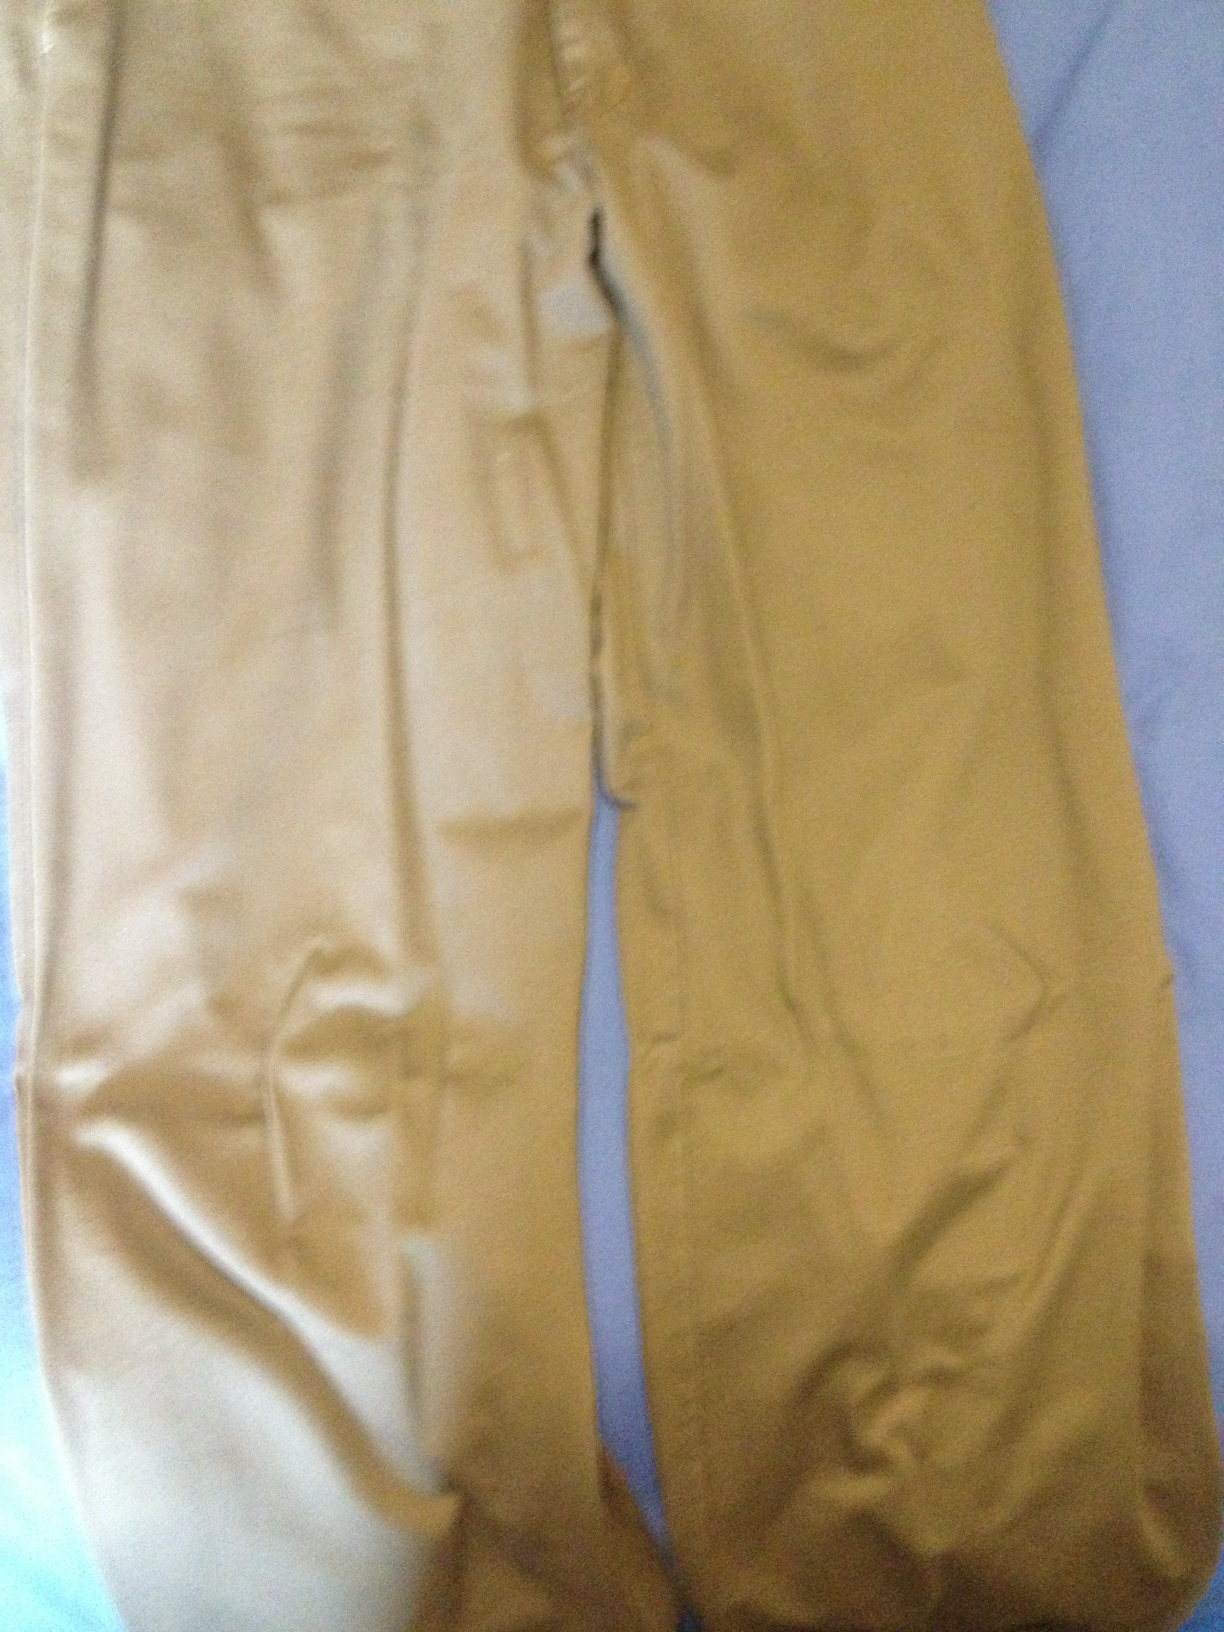What material do these trousers look like they are made of? The trousers appear to have a smooth texture with a slight sheen, suggesting they might be made of a cotton blend, potentially with a bit of synthetic fiber for added durability. 